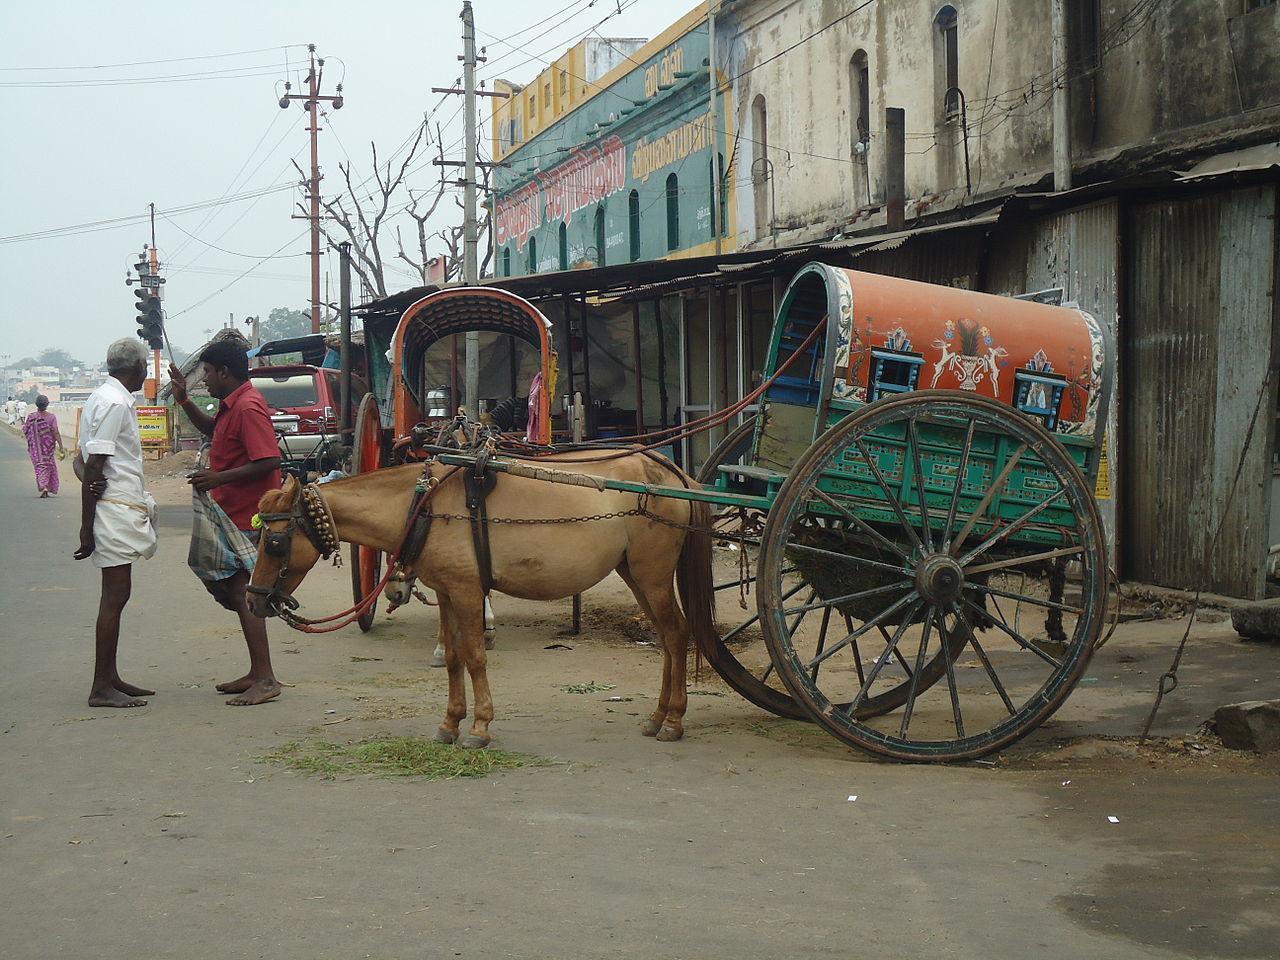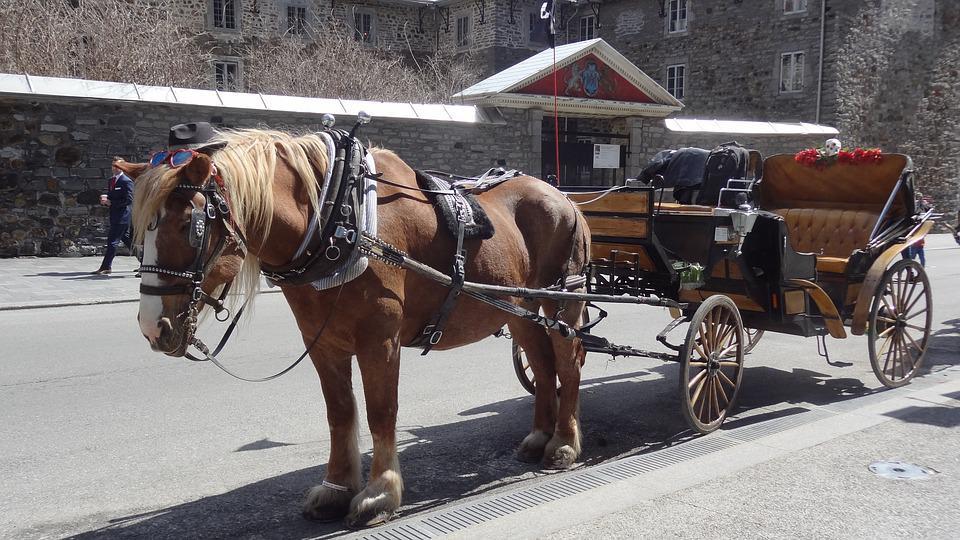The first image is the image on the left, the second image is the image on the right. Examine the images to the left and right. Is the description "At least one horse is white." accurate? Answer yes or no. No. 